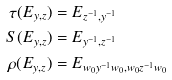Convert formula to latex. <formula><loc_0><loc_0><loc_500><loc_500>\tau ( E _ { y , z } ) & = E _ { z ^ { - 1 } , y ^ { - 1 } } \\ S ( E _ { y , z } ) & = E _ { y ^ { - 1 } , z ^ { - 1 } } \\ \rho ( E _ { y , z } ) & = E _ { w _ { 0 } y ^ { - 1 } w _ { 0 } , w _ { 0 } z ^ { - 1 } w _ { 0 } }</formula> 